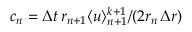<formula> <loc_0><loc_0><loc_500><loc_500>c _ { n } = \Delta t \, r _ { n + 1 } \langle u \rangle _ { n + 1 } ^ { k + 1 } / ( 2 r _ { n } \, \Delta r )</formula> 